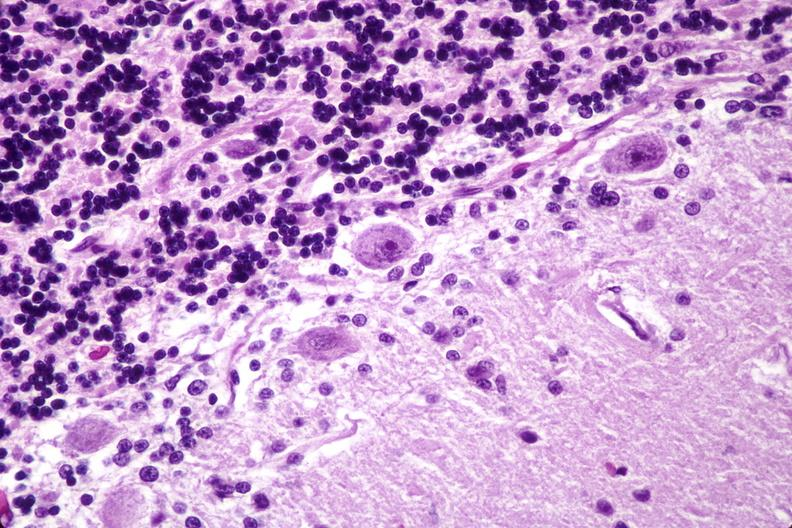does this image show brain lymphoma?
Answer the question using a single word or phrase. Yes 